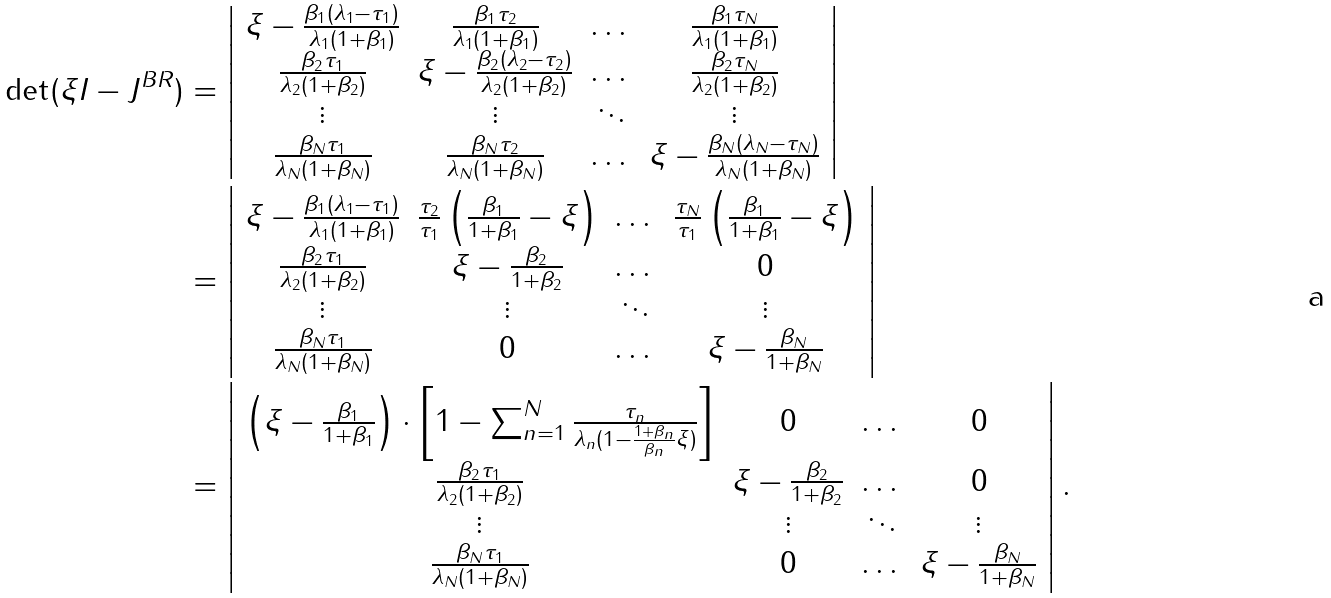Convert formula to latex. <formula><loc_0><loc_0><loc_500><loc_500>\det ( \xi I - J ^ { B R } ) & = \left | \begin{array} { c c c c } \xi - \frac { \beta _ { 1 } ( \lambda _ { 1 } - \tau _ { 1 } ) } { \lambda _ { 1 } ( 1 + \beta _ { 1 } ) } & \frac { \beta _ { 1 } \tau _ { 2 } } { \lambda _ { 1 } ( 1 + \beta _ { 1 } ) } & \dots & \frac { \beta _ { 1 } \tau _ { N } } { \lambda _ { 1 } ( 1 + \beta _ { 1 } ) } \\ \frac { \beta _ { 2 } \tau _ { 1 } } { \lambda _ { 2 } ( 1 + \beta _ { 2 } ) } & \xi - \frac { \beta _ { 2 } ( \lambda _ { 2 } - \tau _ { 2 } ) } { \lambda _ { 2 } ( 1 + \beta _ { 2 } ) } & \dots & \frac { \beta _ { 2 } \tau _ { N } } { \lambda _ { 2 } ( 1 + \beta _ { 2 } ) } \\ \vdots & \vdots & \ddots & \vdots \\ \frac { \beta _ { N } \tau _ { 1 } } { \lambda _ { N } ( 1 + \beta _ { N } ) } & \frac { \beta _ { N } \tau _ { 2 } } { \lambda _ { N } ( 1 + \beta _ { N } ) } & \dots & \xi - \frac { \beta _ { N } ( \lambda _ { N } - \tau _ { N } ) } { \lambda _ { N } ( 1 + \beta _ { N } ) } \\ \end{array} \right | \\ & = \left | \begin{array} { c c c c } \xi - \frac { \beta _ { 1 } ( \lambda _ { 1 } - \tau _ { 1 } ) } { \lambda _ { 1 } ( 1 + \beta _ { 1 } ) } & \frac { \tau _ { 2 } } { \tau _ { 1 } } \left ( \frac { \beta _ { 1 } } { 1 + \beta _ { 1 } } - \xi \right ) & \dots & \frac { \tau _ { N } } { \tau _ { 1 } } \left ( \frac { \beta _ { 1 } } { 1 + \beta _ { 1 } } - \xi \right ) \\ \frac { \beta _ { 2 } \tau _ { 1 } } { \lambda _ { 2 } ( 1 + \beta _ { 2 } ) } & \xi - \frac { \beta _ { 2 } } { 1 + \beta _ { 2 } } & \dots & 0 \\ \vdots & \vdots & \ddots & \vdots \\ \frac { \beta _ { N } \tau _ { 1 } } { \lambda _ { N } ( 1 + \beta _ { N } ) } & 0 & \dots & \xi - \frac { \beta _ { N } } { 1 + \beta _ { N } } \\ \end{array} \right | \\ & = \left | \begin{array} { c c c c } \left ( \xi - \frac { \beta _ { 1 } } { 1 + \beta _ { 1 } } \right ) \cdot \left [ 1 - \sum _ { n = 1 } ^ { N } \frac { \tau _ { n } } { \lambda _ { n } ( 1 - \frac { 1 + \beta _ { n } } { \beta _ { n } } \xi ) } \right ] & 0 & \dots & 0 \\ \frac { \beta _ { 2 } \tau _ { 1 } } { \lambda _ { 2 } ( 1 + \beta _ { 2 } ) } & \xi - \frac { \beta _ { 2 } } { 1 + \beta _ { 2 } } & \dots & 0 \\ \vdots & \vdots & \ddots & \vdots \\ \frac { \beta _ { N } \tau _ { 1 } } { \lambda _ { N } ( 1 + \beta _ { N } ) } & 0 & \dots & \xi - \frac { \beta _ { N } } { 1 + \beta _ { N } } \\ \end{array} \right | .</formula> 